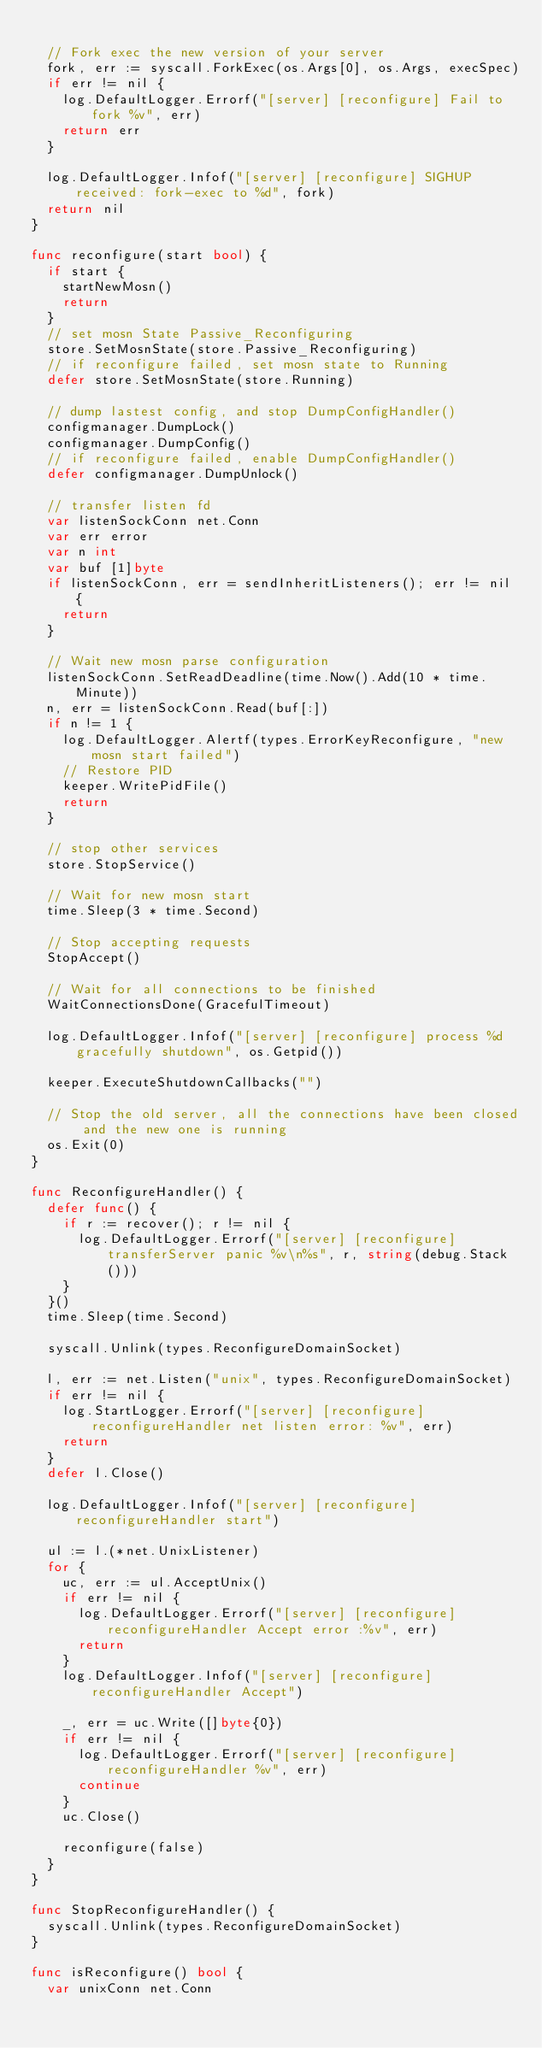Convert code to text. <code><loc_0><loc_0><loc_500><loc_500><_Go_>
	// Fork exec the new version of your server
	fork, err := syscall.ForkExec(os.Args[0], os.Args, execSpec)
	if err != nil {
		log.DefaultLogger.Errorf("[server] [reconfigure] Fail to fork %v", err)
		return err
	}

	log.DefaultLogger.Infof("[server] [reconfigure] SIGHUP received: fork-exec to %d", fork)
	return nil
}

func reconfigure(start bool) {
	if start {
		startNewMosn()
		return
	}
	// set mosn State Passive_Reconfiguring
	store.SetMosnState(store.Passive_Reconfiguring)
	// if reconfigure failed, set mosn state to Running
	defer store.SetMosnState(store.Running)

	// dump lastest config, and stop DumpConfigHandler()
	configmanager.DumpLock()
	configmanager.DumpConfig()
	// if reconfigure failed, enable DumpConfigHandler()
	defer configmanager.DumpUnlock()

	// transfer listen fd
	var listenSockConn net.Conn
	var err error
	var n int
	var buf [1]byte
	if listenSockConn, err = sendInheritListeners(); err != nil {
		return
	}

	// Wait new mosn parse configuration
	listenSockConn.SetReadDeadline(time.Now().Add(10 * time.Minute))
	n, err = listenSockConn.Read(buf[:])
	if n != 1 {
		log.DefaultLogger.Alertf(types.ErrorKeyReconfigure, "new mosn start failed")
		// Restore PID
		keeper.WritePidFile()
		return
	}

	// stop other services
	store.StopService()

	// Wait for new mosn start
	time.Sleep(3 * time.Second)

	// Stop accepting requests
	StopAccept()

	// Wait for all connections to be finished
	WaitConnectionsDone(GracefulTimeout)

	log.DefaultLogger.Infof("[server] [reconfigure] process %d gracefully shutdown", os.Getpid())

	keeper.ExecuteShutdownCallbacks("")

	// Stop the old server, all the connections have been closed and the new one is running
	os.Exit(0)
}

func ReconfigureHandler() {
	defer func() {
		if r := recover(); r != nil {
			log.DefaultLogger.Errorf("[server] [reconfigure] transferServer panic %v\n%s", r, string(debug.Stack()))
		}
	}()
	time.Sleep(time.Second)

	syscall.Unlink(types.ReconfigureDomainSocket)

	l, err := net.Listen("unix", types.ReconfigureDomainSocket)
	if err != nil {
		log.StartLogger.Errorf("[server] [reconfigure] reconfigureHandler net listen error: %v", err)
		return
	}
	defer l.Close()

	log.DefaultLogger.Infof("[server] [reconfigure] reconfigureHandler start")

	ul := l.(*net.UnixListener)
	for {
		uc, err := ul.AcceptUnix()
		if err != nil {
			log.DefaultLogger.Errorf("[server] [reconfigure] reconfigureHandler Accept error :%v", err)
			return
		}
		log.DefaultLogger.Infof("[server] [reconfigure] reconfigureHandler Accept")

		_, err = uc.Write([]byte{0})
		if err != nil {
			log.DefaultLogger.Errorf("[server] [reconfigure] reconfigureHandler %v", err)
			continue
		}
		uc.Close()

		reconfigure(false)
	}
}

func StopReconfigureHandler() {
	syscall.Unlink(types.ReconfigureDomainSocket)
}

func isReconfigure() bool {
	var unixConn net.Conn</code> 